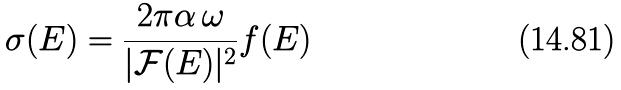<formula> <loc_0><loc_0><loc_500><loc_500>\sigma ( E ) = \frac { 2 \pi \alpha \, \omega } { | \mathcal { F } ( E ) | ^ { 2 } } f ( E )</formula> 